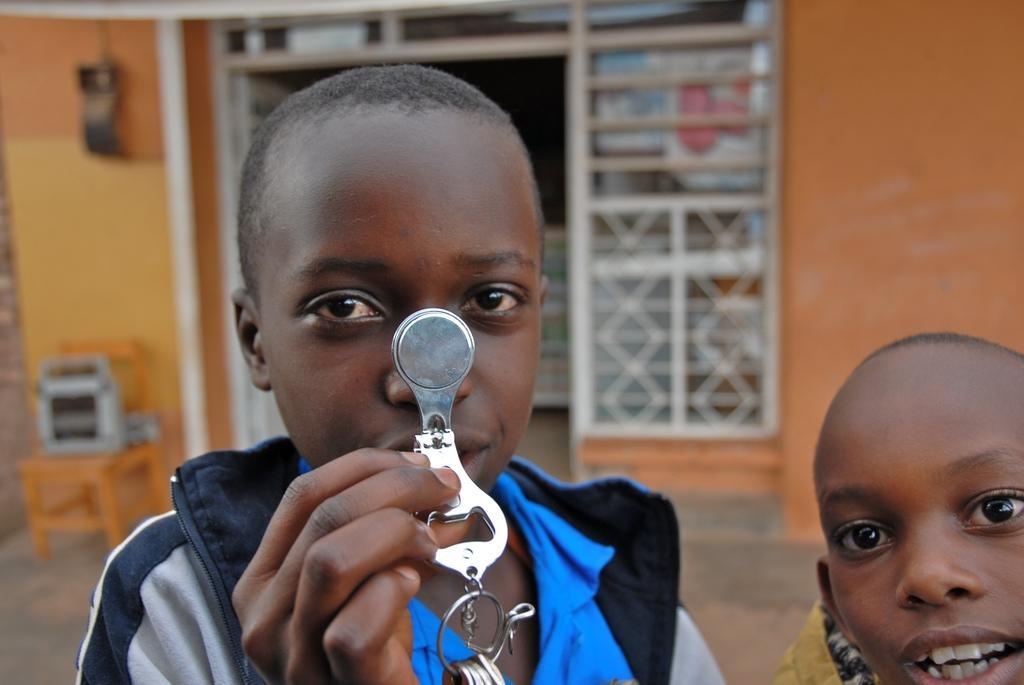Can you describe this image briefly? In the picture I can see a boy holding a stainless steel object in his hand. I can see the face of another boy on the right side. There is a wooden table on the floor on the left side and I can see an object on the table. 